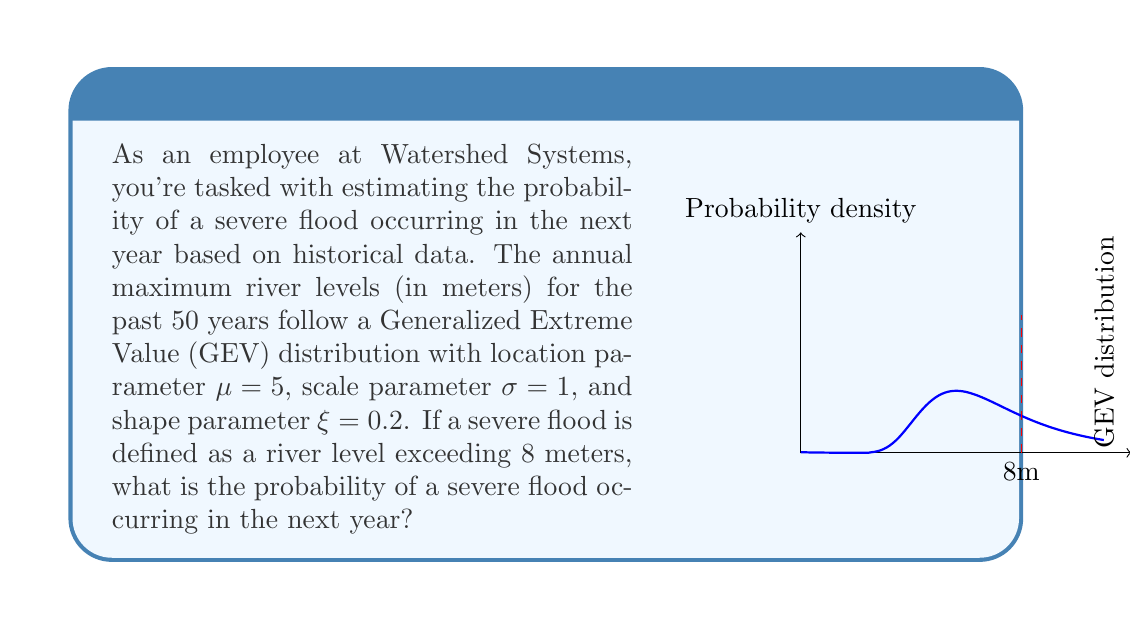Solve this math problem. To solve this problem, we need to use the cumulative distribution function (CDF) of the Generalized Extreme Value (GEV) distribution. The steps are as follows:

1) The CDF of the GEV distribution is given by:

   $$F(x; \mu, \sigma, \xi) = \exp\left(-\left(1 + \xi\frac{x-\mu}{\sigma}\right)^{-1/\xi}\right)$$

   where $\mu$ is the location parameter, $\sigma$ is the scale parameter, and $\xi$ is the shape parameter.

2) We want to find the probability that the river level exceeds 8 meters. This is the complement of the probability that the river level is less than or equal to 8 meters. In mathematical terms:

   $$P(X > 8) = 1 - P(X \leq 8) = 1 - F(8; \mu, \sigma, \xi)$$

3) Let's substitute the given values:
   $x = 8$, $\mu = 5$, $\sigma = 1$, $\xi = 0.2$

4) First, calculate the argument of the exponential function:

   $$1 + \xi\frac{x-\mu}{\sigma} = 1 + 0.2\frac{8-5}{1} = 1 + 0.2(3) = 1.6$$

5) Now, raise this to the power of $-1/\xi$:

   $$(1.6)^{-1/0.2} = (1.6)^{-5} \approx 0.0640$$

6) The CDF value is then:

   $$F(8; 5, 1, 0.2) = \exp(-0.0640) \approx 0.9380$$

7) Finally, we calculate the probability of exceeding 8 meters:

   $$P(X > 8) = 1 - 0.9380 = 0.0620$$

Therefore, the probability of a severe flood (river level exceeding 8 meters) occurring in the next year is approximately 0.0620 or 6.20%.
Answer: 0.0620 (or 6.20%) 